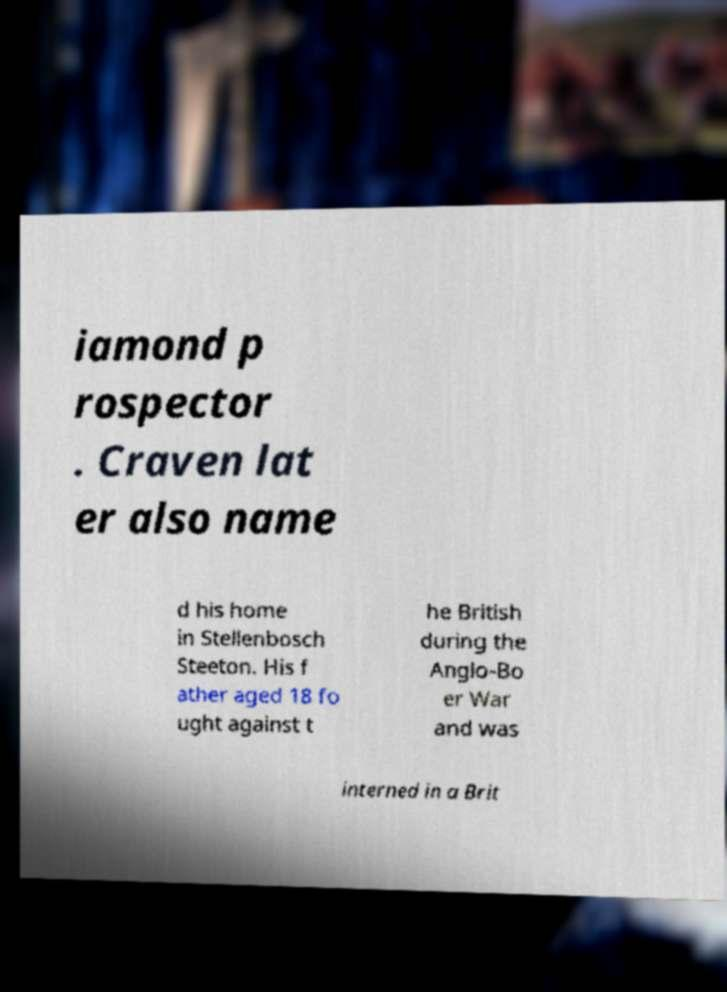What messages or text are displayed in this image? I need them in a readable, typed format. iamond p rospector . Craven lat er also name d his home in Stellenbosch Steeton. His f ather aged 18 fo ught against t he British during the Anglo-Bo er War and was interned in a Brit 